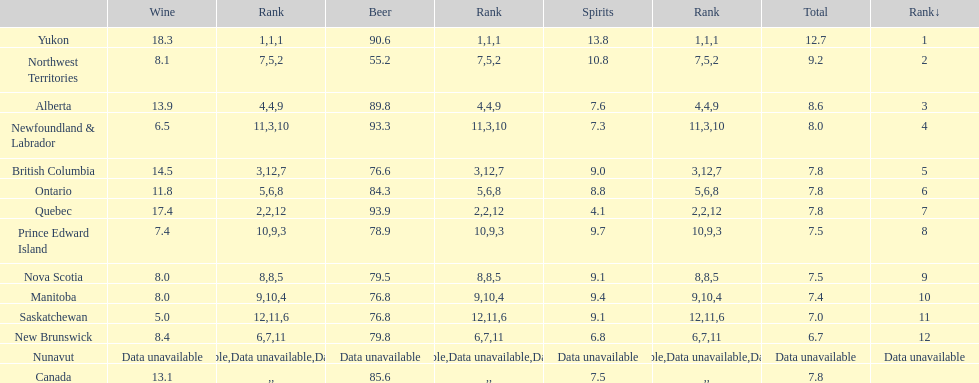In which province is wine consumption the greatest? Yukon. 